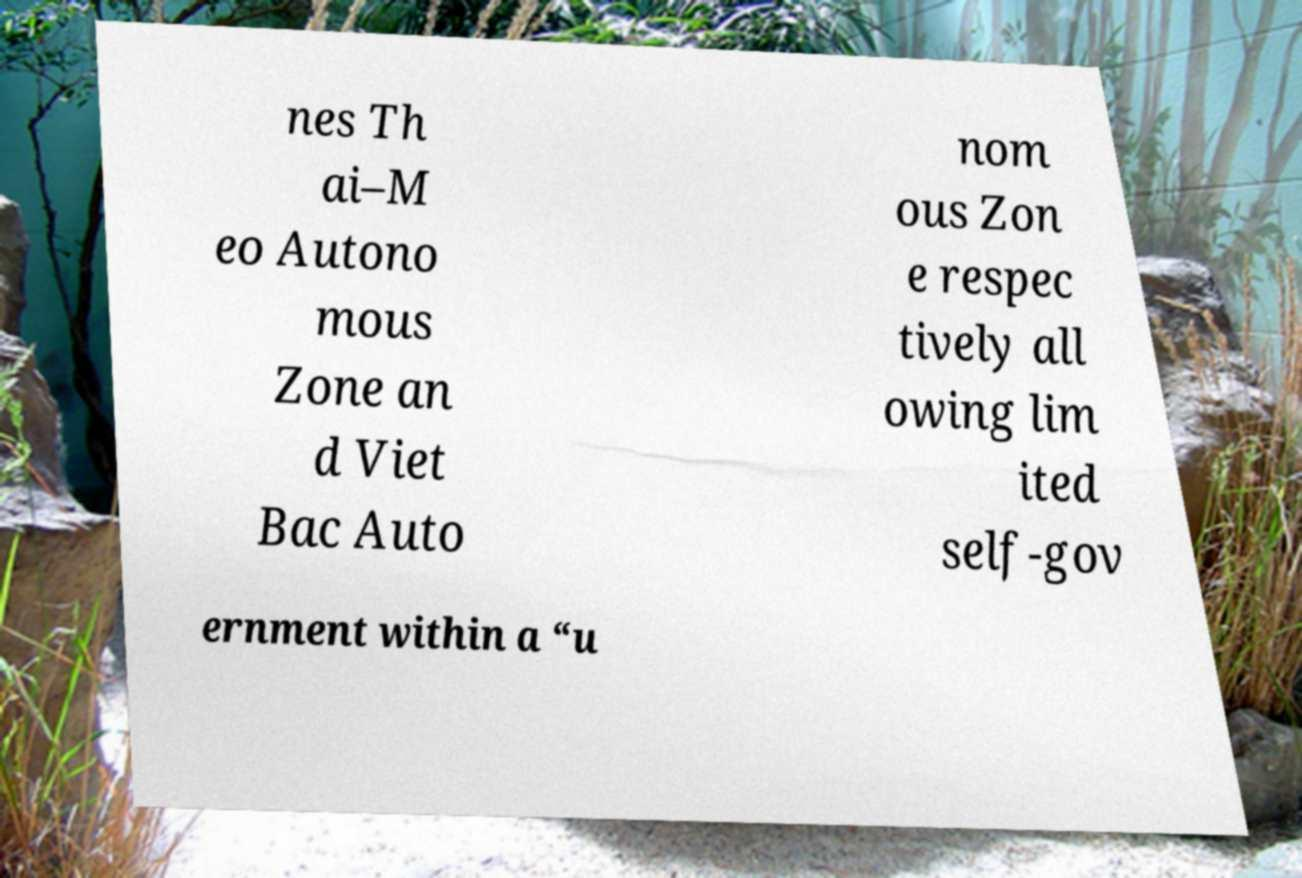Please read and relay the text visible in this image. What does it say? nes Th ai–M eo Autono mous Zone an d Viet Bac Auto nom ous Zon e respec tively all owing lim ited self-gov ernment within a “u 